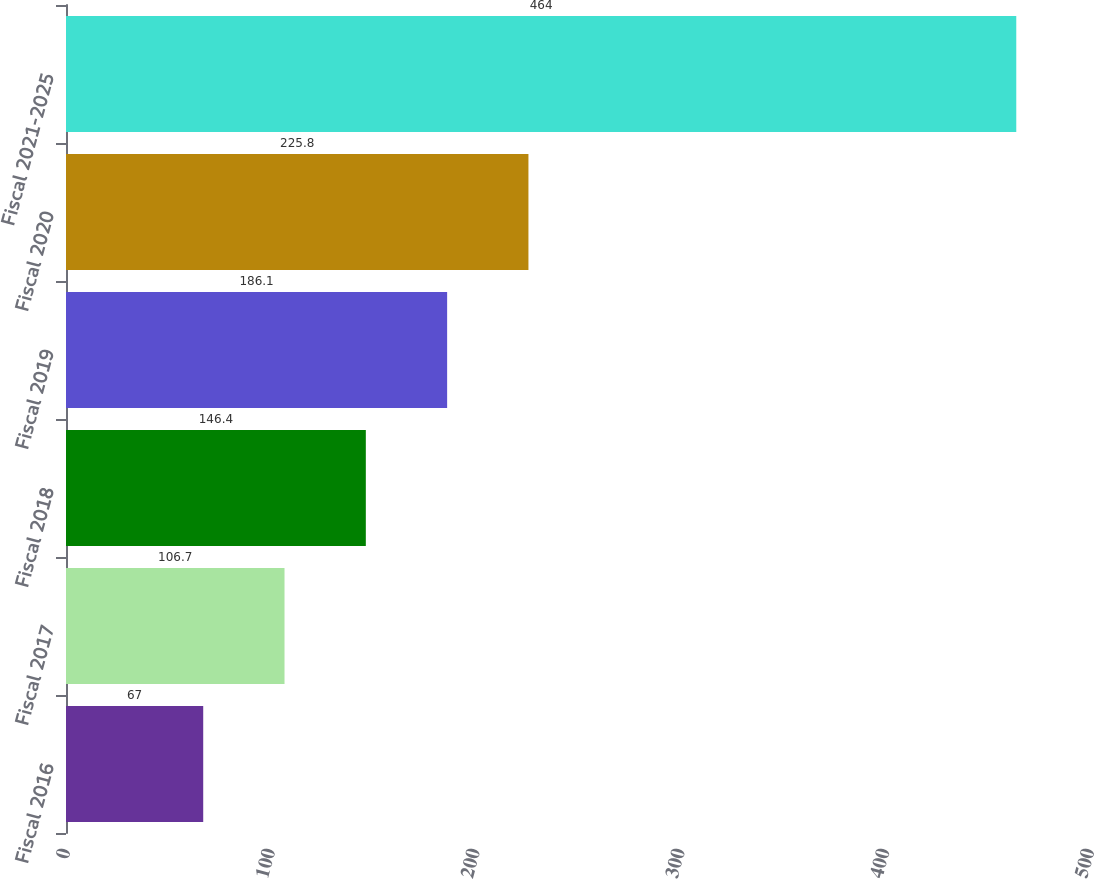<chart> <loc_0><loc_0><loc_500><loc_500><bar_chart><fcel>Fiscal 2016<fcel>Fiscal 2017<fcel>Fiscal 2018<fcel>Fiscal 2019<fcel>Fiscal 2020<fcel>Fiscal 2021-2025<nl><fcel>67<fcel>106.7<fcel>146.4<fcel>186.1<fcel>225.8<fcel>464<nl></chart> 